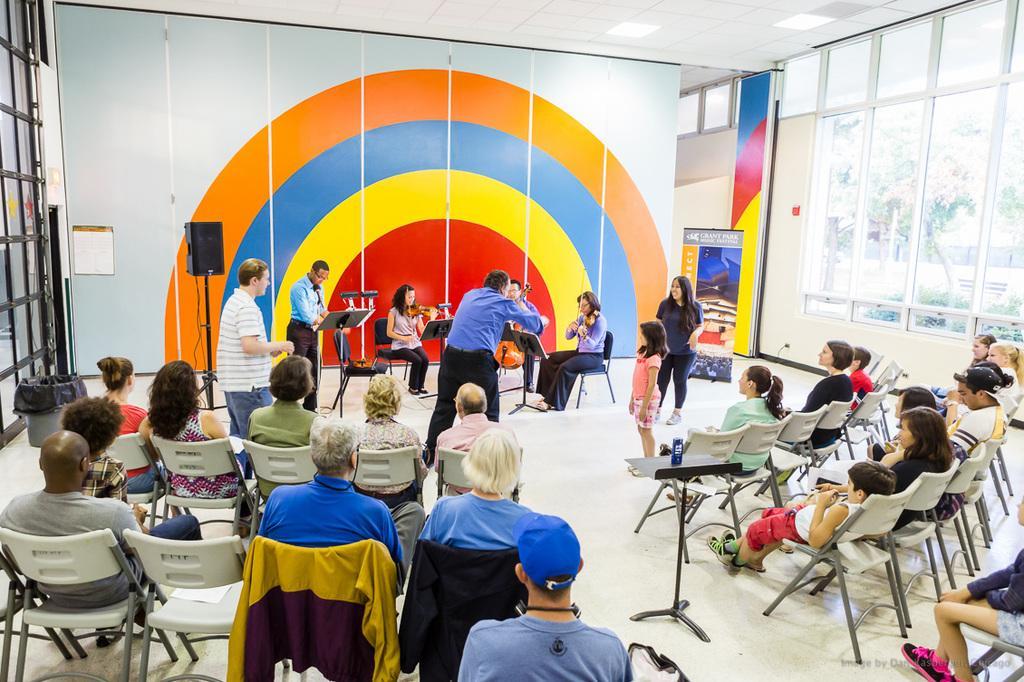How would you summarize this image in a sentence or two? A band of musicians are playing music. There are few people standing around them. There are some people sitting in chairs and enjoying the music. 